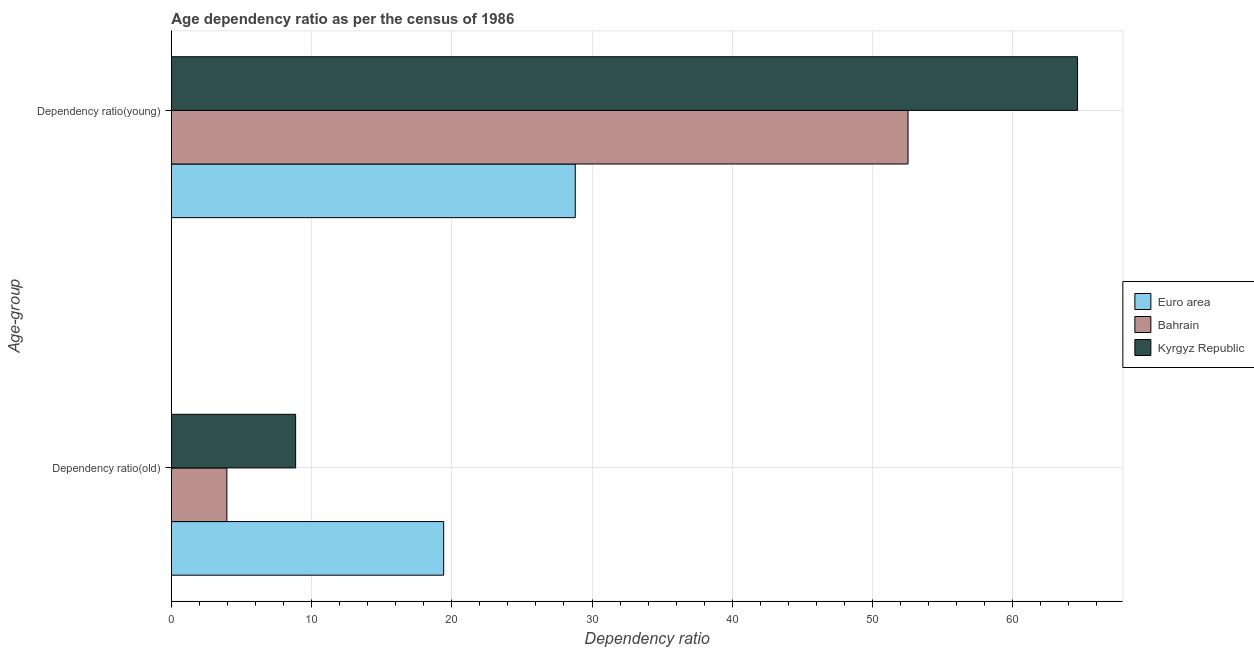How many groups of bars are there?
Your answer should be compact. 2. Are the number of bars per tick equal to the number of legend labels?
Your answer should be compact. Yes. Are the number of bars on each tick of the Y-axis equal?
Make the answer very short. Yes. How many bars are there on the 1st tick from the top?
Your answer should be very brief. 3. How many bars are there on the 2nd tick from the bottom?
Make the answer very short. 3. What is the label of the 1st group of bars from the top?
Offer a very short reply. Dependency ratio(young). What is the age dependency ratio(young) in Bahrain?
Provide a short and direct response. 52.54. Across all countries, what is the maximum age dependency ratio(young)?
Give a very brief answer. 64.63. Across all countries, what is the minimum age dependency ratio(old)?
Make the answer very short. 3.96. In which country was the age dependency ratio(young) maximum?
Give a very brief answer. Kyrgyz Republic. In which country was the age dependency ratio(old) minimum?
Make the answer very short. Bahrain. What is the total age dependency ratio(young) in the graph?
Your response must be concise. 145.97. What is the difference between the age dependency ratio(old) in Bahrain and that in Kyrgyz Republic?
Your response must be concise. -4.9. What is the difference between the age dependency ratio(old) in Kyrgyz Republic and the age dependency ratio(young) in Euro area?
Your answer should be compact. -19.94. What is the average age dependency ratio(old) per country?
Offer a very short reply. 10.75. What is the difference between the age dependency ratio(young) and age dependency ratio(old) in Kyrgyz Republic?
Give a very brief answer. 55.77. In how many countries, is the age dependency ratio(old) greater than 64 ?
Make the answer very short. 0. What is the ratio of the age dependency ratio(young) in Euro area to that in Bahrain?
Ensure brevity in your answer.  0.55. Is the age dependency ratio(young) in Kyrgyz Republic less than that in Bahrain?
Your answer should be compact. No. What does the 1st bar from the top in Dependency ratio(old) represents?
Provide a succinct answer. Kyrgyz Republic. What does the 1st bar from the bottom in Dependency ratio(young) represents?
Offer a very short reply. Euro area. Are all the bars in the graph horizontal?
Your answer should be very brief. Yes. How many countries are there in the graph?
Your answer should be compact. 3. Does the graph contain any zero values?
Your answer should be very brief. No. How are the legend labels stacked?
Provide a succinct answer. Vertical. What is the title of the graph?
Make the answer very short. Age dependency ratio as per the census of 1986. What is the label or title of the X-axis?
Keep it short and to the point. Dependency ratio. What is the label or title of the Y-axis?
Offer a very short reply. Age-group. What is the Dependency ratio in Euro area in Dependency ratio(old)?
Your answer should be compact. 19.42. What is the Dependency ratio in Bahrain in Dependency ratio(old)?
Ensure brevity in your answer.  3.96. What is the Dependency ratio of Kyrgyz Republic in Dependency ratio(old)?
Offer a very short reply. 8.86. What is the Dependency ratio of Euro area in Dependency ratio(young)?
Offer a very short reply. 28.81. What is the Dependency ratio in Bahrain in Dependency ratio(young)?
Keep it short and to the point. 52.54. What is the Dependency ratio of Kyrgyz Republic in Dependency ratio(young)?
Keep it short and to the point. 64.63. Across all Age-group, what is the maximum Dependency ratio in Euro area?
Offer a very short reply. 28.81. Across all Age-group, what is the maximum Dependency ratio of Bahrain?
Provide a succinct answer. 52.54. Across all Age-group, what is the maximum Dependency ratio of Kyrgyz Republic?
Give a very brief answer. 64.63. Across all Age-group, what is the minimum Dependency ratio of Euro area?
Offer a terse response. 19.42. Across all Age-group, what is the minimum Dependency ratio in Bahrain?
Give a very brief answer. 3.96. Across all Age-group, what is the minimum Dependency ratio in Kyrgyz Republic?
Your answer should be very brief. 8.86. What is the total Dependency ratio in Euro area in the graph?
Offer a terse response. 48.23. What is the total Dependency ratio of Bahrain in the graph?
Your answer should be very brief. 56.5. What is the total Dependency ratio in Kyrgyz Republic in the graph?
Offer a very short reply. 73.49. What is the difference between the Dependency ratio of Euro area in Dependency ratio(old) and that in Dependency ratio(young)?
Offer a very short reply. -9.38. What is the difference between the Dependency ratio in Bahrain in Dependency ratio(old) and that in Dependency ratio(young)?
Your answer should be compact. -48.58. What is the difference between the Dependency ratio of Kyrgyz Republic in Dependency ratio(old) and that in Dependency ratio(young)?
Make the answer very short. -55.77. What is the difference between the Dependency ratio in Euro area in Dependency ratio(old) and the Dependency ratio in Bahrain in Dependency ratio(young)?
Ensure brevity in your answer.  -33.12. What is the difference between the Dependency ratio in Euro area in Dependency ratio(old) and the Dependency ratio in Kyrgyz Republic in Dependency ratio(young)?
Provide a succinct answer. -45.21. What is the difference between the Dependency ratio of Bahrain in Dependency ratio(old) and the Dependency ratio of Kyrgyz Republic in Dependency ratio(young)?
Your response must be concise. -60.67. What is the average Dependency ratio of Euro area per Age-group?
Keep it short and to the point. 24.11. What is the average Dependency ratio in Bahrain per Age-group?
Offer a terse response. 28.25. What is the average Dependency ratio in Kyrgyz Republic per Age-group?
Offer a terse response. 36.74. What is the difference between the Dependency ratio in Euro area and Dependency ratio in Bahrain in Dependency ratio(old)?
Your response must be concise. 15.46. What is the difference between the Dependency ratio in Euro area and Dependency ratio in Kyrgyz Republic in Dependency ratio(old)?
Your response must be concise. 10.56. What is the difference between the Dependency ratio of Bahrain and Dependency ratio of Kyrgyz Republic in Dependency ratio(old)?
Your answer should be compact. -4.9. What is the difference between the Dependency ratio of Euro area and Dependency ratio of Bahrain in Dependency ratio(young)?
Keep it short and to the point. -23.73. What is the difference between the Dependency ratio of Euro area and Dependency ratio of Kyrgyz Republic in Dependency ratio(young)?
Your answer should be very brief. -35.82. What is the difference between the Dependency ratio in Bahrain and Dependency ratio in Kyrgyz Republic in Dependency ratio(young)?
Ensure brevity in your answer.  -12.09. What is the ratio of the Dependency ratio of Euro area in Dependency ratio(old) to that in Dependency ratio(young)?
Keep it short and to the point. 0.67. What is the ratio of the Dependency ratio in Bahrain in Dependency ratio(old) to that in Dependency ratio(young)?
Ensure brevity in your answer.  0.08. What is the ratio of the Dependency ratio of Kyrgyz Republic in Dependency ratio(old) to that in Dependency ratio(young)?
Offer a terse response. 0.14. What is the difference between the highest and the second highest Dependency ratio of Euro area?
Make the answer very short. 9.38. What is the difference between the highest and the second highest Dependency ratio of Bahrain?
Give a very brief answer. 48.58. What is the difference between the highest and the second highest Dependency ratio of Kyrgyz Republic?
Provide a succinct answer. 55.77. What is the difference between the highest and the lowest Dependency ratio of Euro area?
Your answer should be compact. 9.38. What is the difference between the highest and the lowest Dependency ratio in Bahrain?
Offer a very short reply. 48.58. What is the difference between the highest and the lowest Dependency ratio of Kyrgyz Republic?
Offer a very short reply. 55.77. 